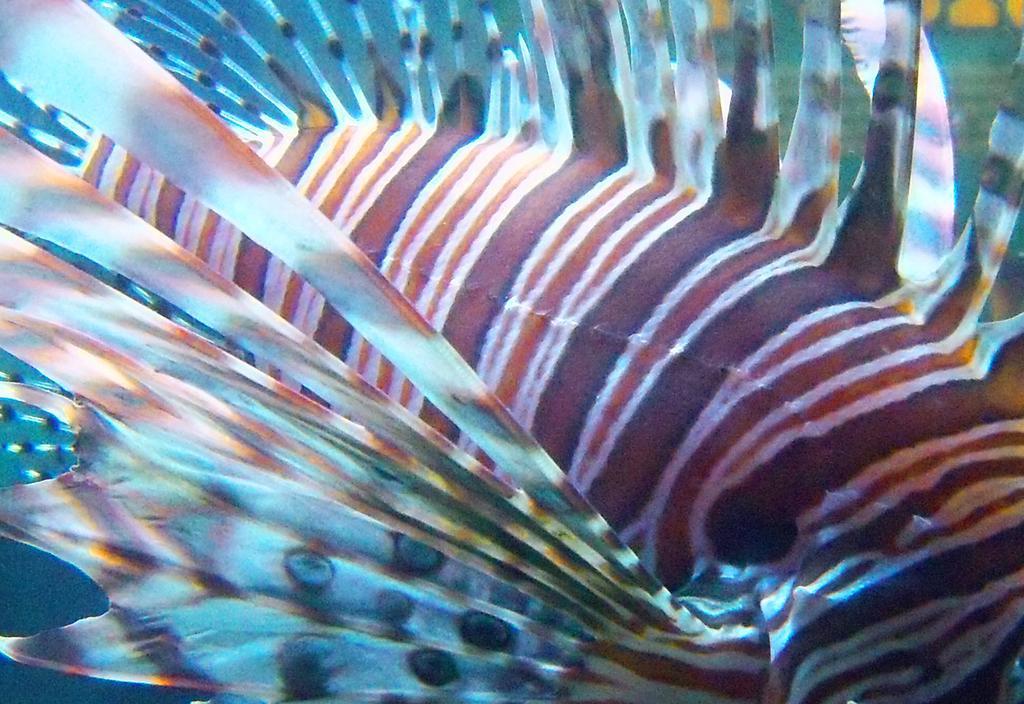How would you summarize this image in a sentence or two? In this image it is looking like an underwater environment. 